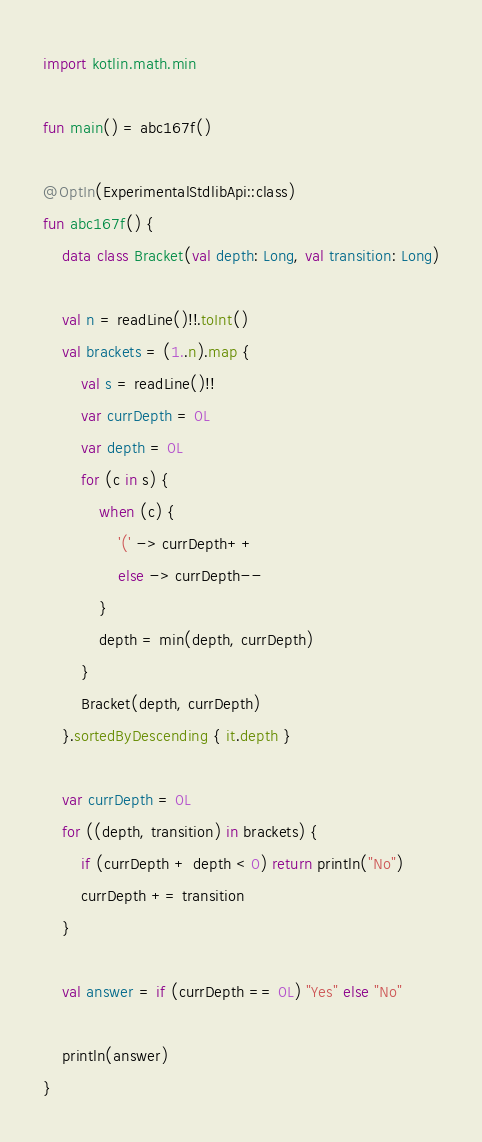<code> <loc_0><loc_0><loc_500><loc_500><_Kotlin_>import kotlin.math.min

fun main() = abc167f()

@OptIn(ExperimentalStdlibApi::class)
fun abc167f() {
    data class Bracket(val depth: Long, val transition: Long)

    val n = readLine()!!.toInt()
    val brackets = (1..n).map {
        val s = readLine()!!
        var currDepth = 0L
        var depth = 0L
        for (c in s) {
            when (c) {
                '(' -> currDepth++
                else -> currDepth--
            }
            depth = min(depth, currDepth)
        }
        Bracket(depth, currDepth)
    }.sortedByDescending { it.depth }

    var currDepth = 0L
    for ((depth, transition) in brackets) {
        if (currDepth + depth < 0) return println("No")
        currDepth += transition
    }

    val answer = if (currDepth == 0L) "Yes" else "No"

    println(answer)
}
</code> 